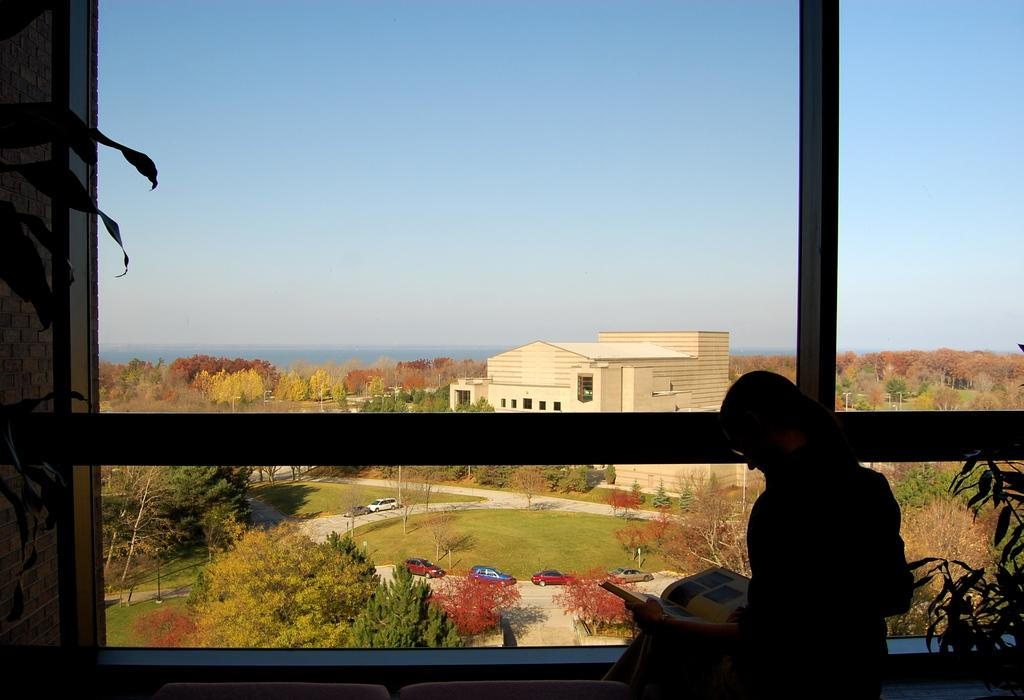Who or what is the main subject in the image? There is a person in the image. What is the person doing in the image? The person is looking at a book. What can be seen in the background of the image? There are trees, cars, and a building in the background of the image. How many dimes are visible on the person's forehead in the image? There are no dimes visible on the person's forehead in the image. What type of turkey can be seen in the background of the image? There is no turkey present in the image; the background features trees, cars, and a building. 